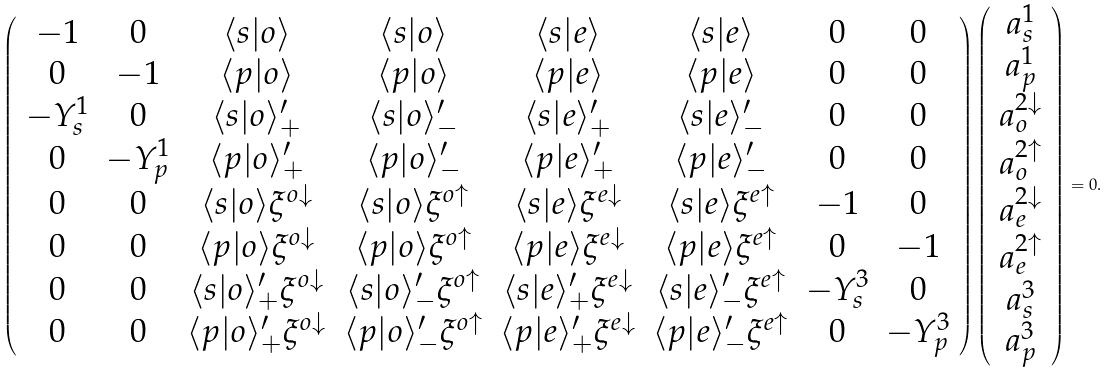<formula> <loc_0><loc_0><loc_500><loc_500>\left ( \begin{array} { c c c c c c c c } - 1 & 0 & \langle s | o \rangle & \langle s | o \rangle & \langle s | e \rangle & \langle s | e \rangle & 0 & 0 \\ 0 & - 1 & \langle p | o \rangle & \langle p | o \rangle & \langle p | e \rangle & \langle p | e \rangle & 0 & 0 \\ - Y _ { s } ^ { 1 } & 0 & \langle s | o \rangle ^ { \prime } _ { + } & \langle s | o \rangle ^ { \prime } _ { - } & \langle s | e \rangle ^ { \prime } _ { + } & \langle s | e \rangle ^ { \prime } _ { - } & 0 & 0 \\ 0 & - Y _ { p } ^ { 1 } & \langle p | o \rangle ^ { \prime } _ { + } & \langle p | o \rangle ^ { \prime } _ { - } & \langle p | e \rangle ^ { \prime } _ { + } & \langle p | e \rangle ^ { \prime } _ { - } & 0 & 0 \\ 0 & 0 & \langle s | o \rangle \xi ^ { o \downarrow } & \langle s | o \rangle \xi ^ { o \uparrow } & \langle s | e \rangle \xi ^ { e \downarrow } & \langle s | e \rangle \xi ^ { e \uparrow } & - 1 & 0 \\ 0 & 0 & \langle p | o \rangle \xi ^ { o \downarrow } & \langle p | o \rangle \xi ^ { o \uparrow } & \langle p | e \rangle \xi ^ { e \downarrow } & \langle p | e \rangle \xi ^ { e \uparrow } & 0 & - 1 \\ 0 & 0 & \langle s | o \rangle ^ { \prime } _ { + } \xi ^ { o \downarrow } & \langle s | o \rangle ^ { \prime } _ { - } \xi ^ { o \uparrow } & \langle s | e \rangle ^ { \prime } _ { + } \xi ^ { e \downarrow } & \langle s | e \rangle ^ { \prime } _ { - } \xi ^ { e \uparrow } & - Y _ { s } ^ { 3 } & 0 \\ 0 & 0 & \langle p | o \rangle ^ { \prime } _ { + } \xi ^ { o \downarrow } & \langle p | o \rangle ^ { \prime } _ { - } \xi ^ { o \uparrow } & \langle p | e \rangle ^ { \prime } _ { + } \xi ^ { e \downarrow } & \langle p | e \rangle ^ { \prime } _ { - } \xi ^ { e \uparrow } & 0 & - Y _ { p } ^ { 3 } \\ \end{array} \right ) \left ( \begin{array} { c } a _ { s } ^ { 1 } \\ a _ { p } ^ { 1 } \\ a _ { o } ^ { 2 \downarrow } \\ a _ { o } ^ { 2 \uparrow } \\ a _ { e } ^ { 2 \downarrow } \\ a _ { e } ^ { 2 \uparrow } \\ a _ { s } ^ { 3 } \\ a _ { p } ^ { 3 } \end{array} \right ) = 0 .</formula> 